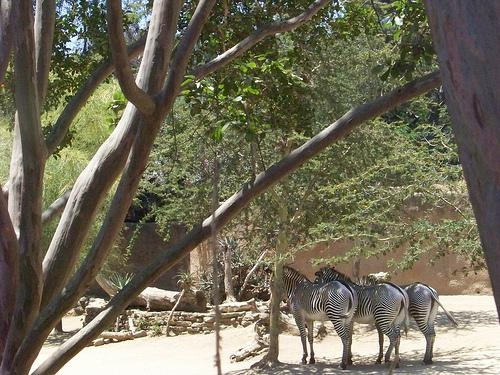Question: where are the zebras standing?
Choices:
A. Grass.
B. Dirt ground.
C. Mud.
D. Concrete.
Answer with the letter. Answer: B Question: where is this taking place?
Choices:
A. The park.
B. The roof.
C. In a zoo.
D. The yard.
Answer with the letter. Answer: C Question: when is this taking place?
Choices:
A. Night.
B. Daytime.
C. Dinner time.
D. Sunset.
Answer with the letter. Answer: B Question: how many zebras are in the photo?
Choices:
A. 1.
B. 0.
C. 4.
D. 3.
Answer with the letter. Answer: D Question: what color are the zebras?
Choices:
A. Gray.
B. Black and white.
C. Blue.
D. Green.
Answer with the letter. Answer: B Question: how many people are in the scene?
Choices:
A. None.
B. 1.
C. 4.
D. 8.
Answer with the letter. Answer: A 